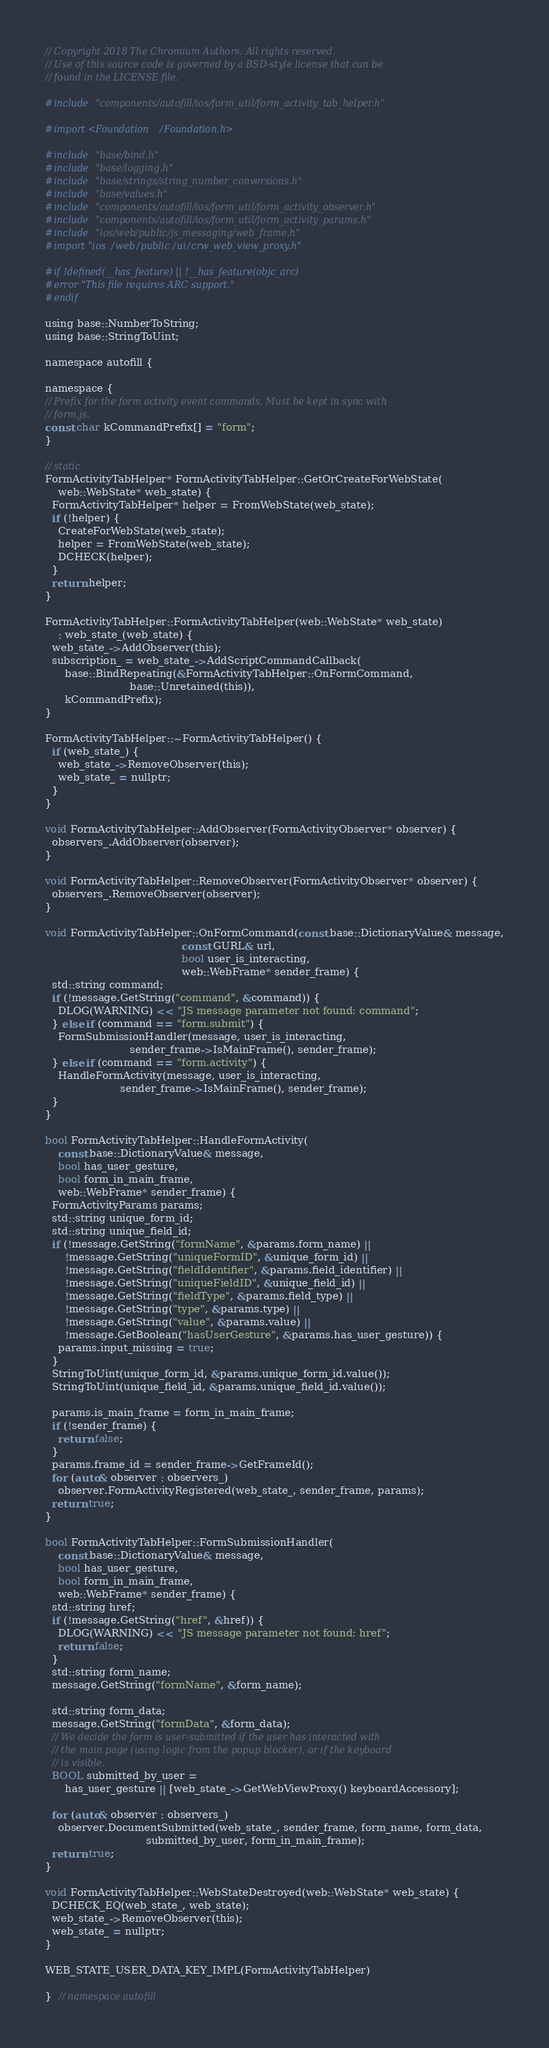<code> <loc_0><loc_0><loc_500><loc_500><_ObjectiveC_>// Copyright 2018 The Chromium Authors. All rights reserved.
// Use of this source code is governed by a BSD-style license that can be
// found in the LICENSE file.

#include "components/autofill/ios/form_util/form_activity_tab_helper.h"

#import <Foundation/Foundation.h>

#include "base/bind.h"
#include "base/logging.h"
#include "base/strings/string_number_conversions.h"
#include "base/values.h"
#include "components/autofill/ios/form_util/form_activity_observer.h"
#include "components/autofill/ios/form_util/form_activity_params.h"
#include "ios/web/public/js_messaging/web_frame.h"
#import "ios/web/public/ui/crw_web_view_proxy.h"

#if !defined(__has_feature) || !__has_feature(objc_arc)
#error "This file requires ARC support."
#endif

using base::NumberToString;
using base::StringToUint;

namespace autofill {

namespace {
// Prefix for the form activity event commands. Must be kept in sync with
// form.js.
const char kCommandPrefix[] = "form";
}

// static
FormActivityTabHelper* FormActivityTabHelper::GetOrCreateForWebState(
    web::WebState* web_state) {
  FormActivityTabHelper* helper = FromWebState(web_state);
  if (!helper) {
    CreateForWebState(web_state);
    helper = FromWebState(web_state);
    DCHECK(helper);
  }
  return helper;
}

FormActivityTabHelper::FormActivityTabHelper(web::WebState* web_state)
    : web_state_(web_state) {
  web_state_->AddObserver(this);
  subscription_ = web_state_->AddScriptCommandCallback(
      base::BindRepeating(&FormActivityTabHelper::OnFormCommand,
                          base::Unretained(this)),
      kCommandPrefix);
}

FormActivityTabHelper::~FormActivityTabHelper() {
  if (web_state_) {
    web_state_->RemoveObserver(this);
    web_state_ = nullptr;
  }
}

void FormActivityTabHelper::AddObserver(FormActivityObserver* observer) {
  observers_.AddObserver(observer);
}

void FormActivityTabHelper::RemoveObserver(FormActivityObserver* observer) {
  observers_.RemoveObserver(observer);
}

void FormActivityTabHelper::OnFormCommand(const base::DictionaryValue& message,
                                          const GURL& url,
                                          bool user_is_interacting,
                                          web::WebFrame* sender_frame) {
  std::string command;
  if (!message.GetString("command", &command)) {
    DLOG(WARNING) << "JS message parameter not found: command";
  } else if (command == "form.submit") {
    FormSubmissionHandler(message, user_is_interacting,
                          sender_frame->IsMainFrame(), sender_frame);
  } else if (command == "form.activity") {
    HandleFormActivity(message, user_is_interacting,
                       sender_frame->IsMainFrame(), sender_frame);
  }
}

bool FormActivityTabHelper::HandleFormActivity(
    const base::DictionaryValue& message,
    bool has_user_gesture,
    bool form_in_main_frame,
    web::WebFrame* sender_frame) {
  FormActivityParams params;
  std::string unique_form_id;
  std::string unique_field_id;
  if (!message.GetString("formName", &params.form_name) ||
      !message.GetString("uniqueFormID", &unique_form_id) ||
      !message.GetString("fieldIdentifier", &params.field_identifier) ||
      !message.GetString("uniqueFieldID", &unique_field_id) ||
      !message.GetString("fieldType", &params.field_type) ||
      !message.GetString("type", &params.type) ||
      !message.GetString("value", &params.value) ||
      !message.GetBoolean("hasUserGesture", &params.has_user_gesture)) {
    params.input_missing = true;
  }
  StringToUint(unique_form_id, &params.unique_form_id.value());
  StringToUint(unique_field_id, &params.unique_field_id.value());

  params.is_main_frame = form_in_main_frame;
  if (!sender_frame) {
    return false;
  }
  params.frame_id = sender_frame->GetFrameId();
  for (auto& observer : observers_)
    observer.FormActivityRegistered(web_state_, sender_frame, params);
  return true;
}

bool FormActivityTabHelper::FormSubmissionHandler(
    const base::DictionaryValue& message,
    bool has_user_gesture,
    bool form_in_main_frame,
    web::WebFrame* sender_frame) {
  std::string href;
  if (!message.GetString("href", &href)) {
    DLOG(WARNING) << "JS message parameter not found: href";
    return false;
  }
  std::string form_name;
  message.GetString("formName", &form_name);

  std::string form_data;
  message.GetString("formData", &form_data);
  // We decide the form is user-submitted if the user has interacted with
  // the main page (using logic from the popup blocker), or if the keyboard
  // is visible.
  BOOL submitted_by_user =
      has_user_gesture || [web_state_->GetWebViewProxy() keyboardAccessory];

  for (auto& observer : observers_)
    observer.DocumentSubmitted(web_state_, sender_frame, form_name, form_data,
                               submitted_by_user, form_in_main_frame);
  return true;
}

void FormActivityTabHelper::WebStateDestroyed(web::WebState* web_state) {
  DCHECK_EQ(web_state_, web_state);
  web_state_->RemoveObserver(this);
  web_state_ = nullptr;
}

WEB_STATE_USER_DATA_KEY_IMPL(FormActivityTabHelper)

}  // namespace autofill
</code> 